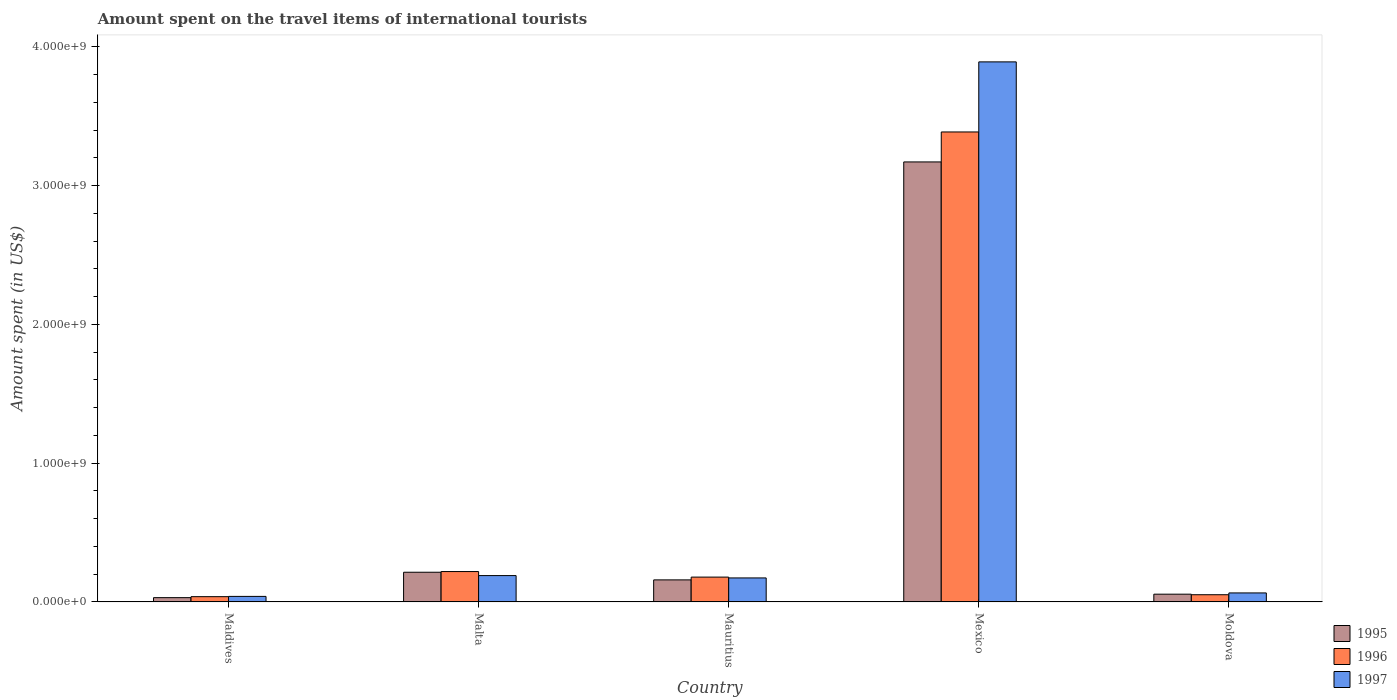How many different coloured bars are there?
Offer a terse response. 3. Are the number of bars on each tick of the X-axis equal?
Ensure brevity in your answer.  Yes. What is the label of the 5th group of bars from the left?
Your answer should be very brief. Moldova. In how many cases, is the number of bars for a given country not equal to the number of legend labels?
Offer a terse response. 0. What is the amount spent on the travel items of international tourists in 1996 in Malta?
Your answer should be very brief. 2.19e+08. Across all countries, what is the maximum amount spent on the travel items of international tourists in 1997?
Provide a succinct answer. 3.89e+09. Across all countries, what is the minimum amount spent on the travel items of international tourists in 1995?
Offer a very short reply. 3.10e+07. In which country was the amount spent on the travel items of international tourists in 1997 minimum?
Keep it short and to the point. Maldives. What is the total amount spent on the travel items of international tourists in 1997 in the graph?
Keep it short and to the point. 4.36e+09. What is the difference between the amount spent on the travel items of international tourists in 1995 in Maldives and that in Malta?
Make the answer very short. -1.83e+08. What is the difference between the amount spent on the travel items of international tourists in 1996 in Maldives and the amount spent on the travel items of international tourists in 1995 in Mexico?
Give a very brief answer. -3.13e+09. What is the average amount spent on the travel items of international tourists in 1996 per country?
Keep it short and to the point. 7.75e+08. What is the difference between the amount spent on the travel items of international tourists of/in 1995 and amount spent on the travel items of international tourists of/in 1996 in Maldives?
Ensure brevity in your answer.  -7.00e+06. In how many countries, is the amount spent on the travel items of international tourists in 1996 greater than 400000000 US$?
Keep it short and to the point. 1. What is the ratio of the amount spent on the travel items of international tourists in 1995 in Malta to that in Mauritius?
Provide a succinct answer. 1.35. Is the amount spent on the travel items of international tourists in 1997 in Malta less than that in Moldova?
Keep it short and to the point. No. What is the difference between the highest and the second highest amount spent on the travel items of international tourists in 1995?
Provide a succinct answer. 2.96e+09. What is the difference between the highest and the lowest amount spent on the travel items of international tourists in 1996?
Your answer should be very brief. 3.35e+09. Is the sum of the amount spent on the travel items of international tourists in 1995 in Maldives and Mexico greater than the maximum amount spent on the travel items of international tourists in 1996 across all countries?
Your answer should be compact. No. What does the 3rd bar from the left in Maldives represents?
Give a very brief answer. 1997. Is it the case that in every country, the sum of the amount spent on the travel items of international tourists in 1997 and amount spent on the travel items of international tourists in 1995 is greater than the amount spent on the travel items of international tourists in 1996?
Provide a succinct answer. Yes. How many bars are there?
Keep it short and to the point. 15. How many countries are there in the graph?
Keep it short and to the point. 5. Where does the legend appear in the graph?
Provide a short and direct response. Bottom right. How many legend labels are there?
Your response must be concise. 3. What is the title of the graph?
Your answer should be compact. Amount spent on the travel items of international tourists. Does "2011" appear as one of the legend labels in the graph?
Offer a terse response. No. What is the label or title of the Y-axis?
Offer a terse response. Amount spent (in US$). What is the Amount spent (in US$) of 1995 in Maldives?
Make the answer very short. 3.10e+07. What is the Amount spent (in US$) of 1996 in Maldives?
Your answer should be very brief. 3.80e+07. What is the Amount spent (in US$) in 1997 in Maldives?
Provide a succinct answer. 4.00e+07. What is the Amount spent (in US$) in 1995 in Malta?
Give a very brief answer. 2.14e+08. What is the Amount spent (in US$) of 1996 in Malta?
Keep it short and to the point. 2.19e+08. What is the Amount spent (in US$) of 1997 in Malta?
Provide a succinct answer. 1.90e+08. What is the Amount spent (in US$) of 1995 in Mauritius?
Make the answer very short. 1.59e+08. What is the Amount spent (in US$) of 1996 in Mauritius?
Provide a short and direct response. 1.79e+08. What is the Amount spent (in US$) of 1997 in Mauritius?
Give a very brief answer. 1.73e+08. What is the Amount spent (in US$) in 1995 in Mexico?
Offer a terse response. 3.17e+09. What is the Amount spent (in US$) of 1996 in Mexico?
Offer a very short reply. 3.39e+09. What is the Amount spent (in US$) of 1997 in Mexico?
Your answer should be compact. 3.89e+09. What is the Amount spent (in US$) in 1995 in Moldova?
Keep it short and to the point. 5.60e+07. What is the Amount spent (in US$) in 1996 in Moldova?
Provide a succinct answer. 5.20e+07. What is the Amount spent (in US$) in 1997 in Moldova?
Provide a succinct answer. 6.50e+07. Across all countries, what is the maximum Amount spent (in US$) of 1995?
Provide a succinct answer. 3.17e+09. Across all countries, what is the maximum Amount spent (in US$) in 1996?
Provide a short and direct response. 3.39e+09. Across all countries, what is the maximum Amount spent (in US$) of 1997?
Provide a short and direct response. 3.89e+09. Across all countries, what is the minimum Amount spent (in US$) in 1995?
Make the answer very short. 3.10e+07. Across all countries, what is the minimum Amount spent (in US$) in 1996?
Provide a short and direct response. 3.80e+07. Across all countries, what is the minimum Amount spent (in US$) in 1997?
Ensure brevity in your answer.  4.00e+07. What is the total Amount spent (in US$) of 1995 in the graph?
Offer a terse response. 3.63e+09. What is the total Amount spent (in US$) in 1996 in the graph?
Ensure brevity in your answer.  3.88e+09. What is the total Amount spent (in US$) of 1997 in the graph?
Provide a succinct answer. 4.36e+09. What is the difference between the Amount spent (in US$) of 1995 in Maldives and that in Malta?
Offer a terse response. -1.83e+08. What is the difference between the Amount spent (in US$) in 1996 in Maldives and that in Malta?
Keep it short and to the point. -1.81e+08. What is the difference between the Amount spent (in US$) in 1997 in Maldives and that in Malta?
Make the answer very short. -1.50e+08. What is the difference between the Amount spent (in US$) of 1995 in Maldives and that in Mauritius?
Give a very brief answer. -1.28e+08. What is the difference between the Amount spent (in US$) of 1996 in Maldives and that in Mauritius?
Ensure brevity in your answer.  -1.41e+08. What is the difference between the Amount spent (in US$) in 1997 in Maldives and that in Mauritius?
Keep it short and to the point. -1.33e+08. What is the difference between the Amount spent (in US$) in 1995 in Maldives and that in Mexico?
Make the answer very short. -3.14e+09. What is the difference between the Amount spent (in US$) of 1996 in Maldives and that in Mexico?
Your response must be concise. -3.35e+09. What is the difference between the Amount spent (in US$) in 1997 in Maldives and that in Mexico?
Make the answer very short. -3.85e+09. What is the difference between the Amount spent (in US$) of 1995 in Maldives and that in Moldova?
Your response must be concise. -2.50e+07. What is the difference between the Amount spent (in US$) of 1996 in Maldives and that in Moldova?
Keep it short and to the point. -1.40e+07. What is the difference between the Amount spent (in US$) of 1997 in Maldives and that in Moldova?
Keep it short and to the point. -2.50e+07. What is the difference between the Amount spent (in US$) of 1995 in Malta and that in Mauritius?
Ensure brevity in your answer.  5.50e+07. What is the difference between the Amount spent (in US$) of 1996 in Malta and that in Mauritius?
Your answer should be very brief. 4.00e+07. What is the difference between the Amount spent (in US$) of 1997 in Malta and that in Mauritius?
Provide a short and direct response. 1.70e+07. What is the difference between the Amount spent (in US$) of 1995 in Malta and that in Mexico?
Your answer should be compact. -2.96e+09. What is the difference between the Amount spent (in US$) in 1996 in Malta and that in Mexico?
Offer a terse response. -3.17e+09. What is the difference between the Amount spent (in US$) in 1997 in Malta and that in Mexico?
Your answer should be very brief. -3.70e+09. What is the difference between the Amount spent (in US$) of 1995 in Malta and that in Moldova?
Your answer should be very brief. 1.58e+08. What is the difference between the Amount spent (in US$) of 1996 in Malta and that in Moldova?
Offer a terse response. 1.67e+08. What is the difference between the Amount spent (in US$) of 1997 in Malta and that in Moldova?
Offer a terse response. 1.25e+08. What is the difference between the Amount spent (in US$) in 1995 in Mauritius and that in Mexico?
Your answer should be very brief. -3.01e+09. What is the difference between the Amount spent (in US$) of 1996 in Mauritius and that in Mexico?
Offer a very short reply. -3.21e+09. What is the difference between the Amount spent (in US$) in 1997 in Mauritius and that in Mexico?
Your answer should be compact. -3.72e+09. What is the difference between the Amount spent (in US$) of 1995 in Mauritius and that in Moldova?
Your response must be concise. 1.03e+08. What is the difference between the Amount spent (in US$) of 1996 in Mauritius and that in Moldova?
Provide a short and direct response. 1.27e+08. What is the difference between the Amount spent (in US$) of 1997 in Mauritius and that in Moldova?
Your response must be concise. 1.08e+08. What is the difference between the Amount spent (in US$) of 1995 in Mexico and that in Moldova?
Make the answer very short. 3.12e+09. What is the difference between the Amount spent (in US$) of 1996 in Mexico and that in Moldova?
Your answer should be compact. 3.34e+09. What is the difference between the Amount spent (in US$) of 1997 in Mexico and that in Moldova?
Ensure brevity in your answer.  3.83e+09. What is the difference between the Amount spent (in US$) of 1995 in Maldives and the Amount spent (in US$) of 1996 in Malta?
Provide a short and direct response. -1.88e+08. What is the difference between the Amount spent (in US$) in 1995 in Maldives and the Amount spent (in US$) in 1997 in Malta?
Your answer should be very brief. -1.59e+08. What is the difference between the Amount spent (in US$) of 1996 in Maldives and the Amount spent (in US$) of 1997 in Malta?
Your answer should be very brief. -1.52e+08. What is the difference between the Amount spent (in US$) in 1995 in Maldives and the Amount spent (in US$) in 1996 in Mauritius?
Keep it short and to the point. -1.48e+08. What is the difference between the Amount spent (in US$) of 1995 in Maldives and the Amount spent (in US$) of 1997 in Mauritius?
Make the answer very short. -1.42e+08. What is the difference between the Amount spent (in US$) of 1996 in Maldives and the Amount spent (in US$) of 1997 in Mauritius?
Your answer should be compact. -1.35e+08. What is the difference between the Amount spent (in US$) in 1995 in Maldives and the Amount spent (in US$) in 1996 in Mexico?
Provide a short and direct response. -3.36e+09. What is the difference between the Amount spent (in US$) in 1995 in Maldives and the Amount spent (in US$) in 1997 in Mexico?
Provide a short and direct response. -3.86e+09. What is the difference between the Amount spent (in US$) of 1996 in Maldives and the Amount spent (in US$) of 1997 in Mexico?
Your answer should be compact. -3.85e+09. What is the difference between the Amount spent (in US$) in 1995 in Maldives and the Amount spent (in US$) in 1996 in Moldova?
Your answer should be very brief. -2.10e+07. What is the difference between the Amount spent (in US$) of 1995 in Maldives and the Amount spent (in US$) of 1997 in Moldova?
Keep it short and to the point. -3.40e+07. What is the difference between the Amount spent (in US$) in 1996 in Maldives and the Amount spent (in US$) in 1997 in Moldova?
Give a very brief answer. -2.70e+07. What is the difference between the Amount spent (in US$) of 1995 in Malta and the Amount spent (in US$) of 1996 in Mauritius?
Your answer should be very brief. 3.50e+07. What is the difference between the Amount spent (in US$) in 1995 in Malta and the Amount spent (in US$) in 1997 in Mauritius?
Make the answer very short. 4.10e+07. What is the difference between the Amount spent (in US$) in 1996 in Malta and the Amount spent (in US$) in 1997 in Mauritius?
Make the answer very short. 4.60e+07. What is the difference between the Amount spent (in US$) in 1995 in Malta and the Amount spent (in US$) in 1996 in Mexico?
Your response must be concise. -3.17e+09. What is the difference between the Amount spent (in US$) of 1995 in Malta and the Amount spent (in US$) of 1997 in Mexico?
Ensure brevity in your answer.  -3.68e+09. What is the difference between the Amount spent (in US$) in 1996 in Malta and the Amount spent (in US$) in 1997 in Mexico?
Offer a very short reply. -3.67e+09. What is the difference between the Amount spent (in US$) in 1995 in Malta and the Amount spent (in US$) in 1996 in Moldova?
Your answer should be compact. 1.62e+08. What is the difference between the Amount spent (in US$) of 1995 in Malta and the Amount spent (in US$) of 1997 in Moldova?
Offer a terse response. 1.49e+08. What is the difference between the Amount spent (in US$) in 1996 in Malta and the Amount spent (in US$) in 1997 in Moldova?
Provide a short and direct response. 1.54e+08. What is the difference between the Amount spent (in US$) in 1995 in Mauritius and the Amount spent (in US$) in 1996 in Mexico?
Your answer should be very brief. -3.23e+09. What is the difference between the Amount spent (in US$) of 1995 in Mauritius and the Amount spent (in US$) of 1997 in Mexico?
Your answer should be compact. -3.73e+09. What is the difference between the Amount spent (in US$) in 1996 in Mauritius and the Amount spent (in US$) in 1997 in Mexico?
Provide a short and direct response. -3.71e+09. What is the difference between the Amount spent (in US$) in 1995 in Mauritius and the Amount spent (in US$) in 1996 in Moldova?
Your answer should be compact. 1.07e+08. What is the difference between the Amount spent (in US$) of 1995 in Mauritius and the Amount spent (in US$) of 1997 in Moldova?
Provide a succinct answer. 9.40e+07. What is the difference between the Amount spent (in US$) in 1996 in Mauritius and the Amount spent (in US$) in 1997 in Moldova?
Offer a terse response. 1.14e+08. What is the difference between the Amount spent (in US$) of 1995 in Mexico and the Amount spent (in US$) of 1996 in Moldova?
Offer a terse response. 3.12e+09. What is the difference between the Amount spent (in US$) of 1995 in Mexico and the Amount spent (in US$) of 1997 in Moldova?
Give a very brief answer. 3.11e+09. What is the difference between the Amount spent (in US$) in 1996 in Mexico and the Amount spent (in US$) in 1997 in Moldova?
Your response must be concise. 3.32e+09. What is the average Amount spent (in US$) in 1995 per country?
Your answer should be very brief. 7.26e+08. What is the average Amount spent (in US$) in 1996 per country?
Provide a short and direct response. 7.75e+08. What is the average Amount spent (in US$) in 1997 per country?
Your answer should be very brief. 8.72e+08. What is the difference between the Amount spent (in US$) in 1995 and Amount spent (in US$) in 1996 in Maldives?
Provide a short and direct response. -7.00e+06. What is the difference between the Amount spent (in US$) in 1995 and Amount spent (in US$) in 1997 in Maldives?
Your answer should be very brief. -9.00e+06. What is the difference between the Amount spent (in US$) of 1996 and Amount spent (in US$) of 1997 in Maldives?
Give a very brief answer. -2.00e+06. What is the difference between the Amount spent (in US$) of 1995 and Amount spent (in US$) of 1996 in Malta?
Your answer should be very brief. -5.00e+06. What is the difference between the Amount spent (in US$) of 1995 and Amount spent (in US$) of 1997 in Malta?
Keep it short and to the point. 2.40e+07. What is the difference between the Amount spent (in US$) in 1996 and Amount spent (in US$) in 1997 in Malta?
Your response must be concise. 2.90e+07. What is the difference between the Amount spent (in US$) of 1995 and Amount spent (in US$) of 1996 in Mauritius?
Your response must be concise. -2.00e+07. What is the difference between the Amount spent (in US$) in 1995 and Amount spent (in US$) in 1997 in Mauritius?
Your response must be concise. -1.40e+07. What is the difference between the Amount spent (in US$) of 1996 and Amount spent (in US$) of 1997 in Mauritius?
Give a very brief answer. 6.00e+06. What is the difference between the Amount spent (in US$) in 1995 and Amount spent (in US$) in 1996 in Mexico?
Give a very brief answer. -2.16e+08. What is the difference between the Amount spent (in US$) in 1995 and Amount spent (in US$) in 1997 in Mexico?
Offer a very short reply. -7.21e+08. What is the difference between the Amount spent (in US$) of 1996 and Amount spent (in US$) of 1997 in Mexico?
Your response must be concise. -5.05e+08. What is the difference between the Amount spent (in US$) of 1995 and Amount spent (in US$) of 1996 in Moldova?
Offer a very short reply. 4.00e+06. What is the difference between the Amount spent (in US$) of 1995 and Amount spent (in US$) of 1997 in Moldova?
Offer a very short reply. -9.00e+06. What is the difference between the Amount spent (in US$) in 1996 and Amount spent (in US$) in 1997 in Moldova?
Make the answer very short. -1.30e+07. What is the ratio of the Amount spent (in US$) in 1995 in Maldives to that in Malta?
Make the answer very short. 0.14. What is the ratio of the Amount spent (in US$) of 1996 in Maldives to that in Malta?
Your answer should be very brief. 0.17. What is the ratio of the Amount spent (in US$) in 1997 in Maldives to that in Malta?
Provide a succinct answer. 0.21. What is the ratio of the Amount spent (in US$) of 1995 in Maldives to that in Mauritius?
Offer a terse response. 0.2. What is the ratio of the Amount spent (in US$) of 1996 in Maldives to that in Mauritius?
Offer a terse response. 0.21. What is the ratio of the Amount spent (in US$) of 1997 in Maldives to that in Mauritius?
Offer a terse response. 0.23. What is the ratio of the Amount spent (in US$) in 1995 in Maldives to that in Mexico?
Provide a short and direct response. 0.01. What is the ratio of the Amount spent (in US$) in 1996 in Maldives to that in Mexico?
Offer a very short reply. 0.01. What is the ratio of the Amount spent (in US$) in 1997 in Maldives to that in Mexico?
Your response must be concise. 0.01. What is the ratio of the Amount spent (in US$) in 1995 in Maldives to that in Moldova?
Offer a very short reply. 0.55. What is the ratio of the Amount spent (in US$) of 1996 in Maldives to that in Moldova?
Your answer should be compact. 0.73. What is the ratio of the Amount spent (in US$) of 1997 in Maldives to that in Moldova?
Offer a terse response. 0.62. What is the ratio of the Amount spent (in US$) in 1995 in Malta to that in Mauritius?
Offer a terse response. 1.35. What is the ratio of the Amount spent (in US$) of 1996 in Malta to that in Mauritius?
Keep it short and to the point. 1.22. What is the ratio of the Amount spent (in US$) of 1997 in Malta to that in Mauritius?
Your response must be concise. 1.1. What is the ratio of the Amount spent (in US$) in 1995 in Malta to that in Mexico?
Your response must be concise. 0.07. What is the ratio of the Amount spent (in US$) of 1996 in Malta to that in Mexico?
Provide a short and direct response. 0.06. What is the ratio of the Amount spent (in US$) in 1997 in Malta to that in Mexico?
Your response must be concise. 0.05. What is the ratio of the Amount spent (in US$) of 1995 in Malta to that in Moldova?
Provide a succinct answer. 3.82. What is the ratio of the Amount spent (in US$) of 1996 in Malta to that in Moldova?
Keep it short and to the point. 4.21. What is the ratio of the Amount spent (in US$) in 1997 in Malta to that in Moldova?
Keep it short and to the point. 2.92. What is the ratio of the Amount spent (in US$) in 1995 in Mauritius to that in Mexico?
Ensure brevity in your answer.  0.05. What is the ratio of the Amount spent (in US$) of 1996 in Mauritius to that in Mexico?
Your answer should be compact. 0.05. What is the ratio of the Amount spent (in US$) of 1997 in Mauritius to that in Mexico?
Provide a succinct answer. 0.04. What is the ratio of the Amount spent (in US$) in 1995 in Mauritius to that in Moldova?
Make the answer very short. 2.84. What is the ratio of the Amount spent (in US$) of 1996 in Mauritius to that in Moldova?
Give a very brief answer. 3.44. What is the ratio of the Amount spent (in US$) in 1997 in Mauritius to that in Moldova?
Your answer should be compact. 2.66. What is the ratio of the Amount spent (in US$) of 1995 in Mexico to that in Moldova?
Make the answer very short. 56.62. What is the ratio of the Amount spent (in US$) of 1996 in Mexico to that in Moldova?
Your answer should be very brief. 65.13. What is the ratio of the Amount spent (in US$) in 1997 in Mexico to that in Moldova?
Provide a short and direct response. 59.88. What is the difference between the highest and the second highest Amount spent (in US$) of 1995?
Give a very brief answer. 2.96e+09. What is the difference between the highest and the second highest Amount spent (in US$) of 1996?
Your response must be concise. 3.17e+09. What is the difference between the highest and the second highest Amount spent (in US$) of 1997?
Offer a terse response. 3.70e+09. What is the difference between the highest and the lowest Amount spent (in US$) in 1995?
Your answer should be compact. 3.14e+09. What is the difference between the highest and the lowest Amount spent (in US$) of 1996?
Offer a terse response. 3.35e+09. What is the difference between the highest and the lowest Amount spent (in US$) in 1997?
Your answer should be very brief. 3.85e+09. 